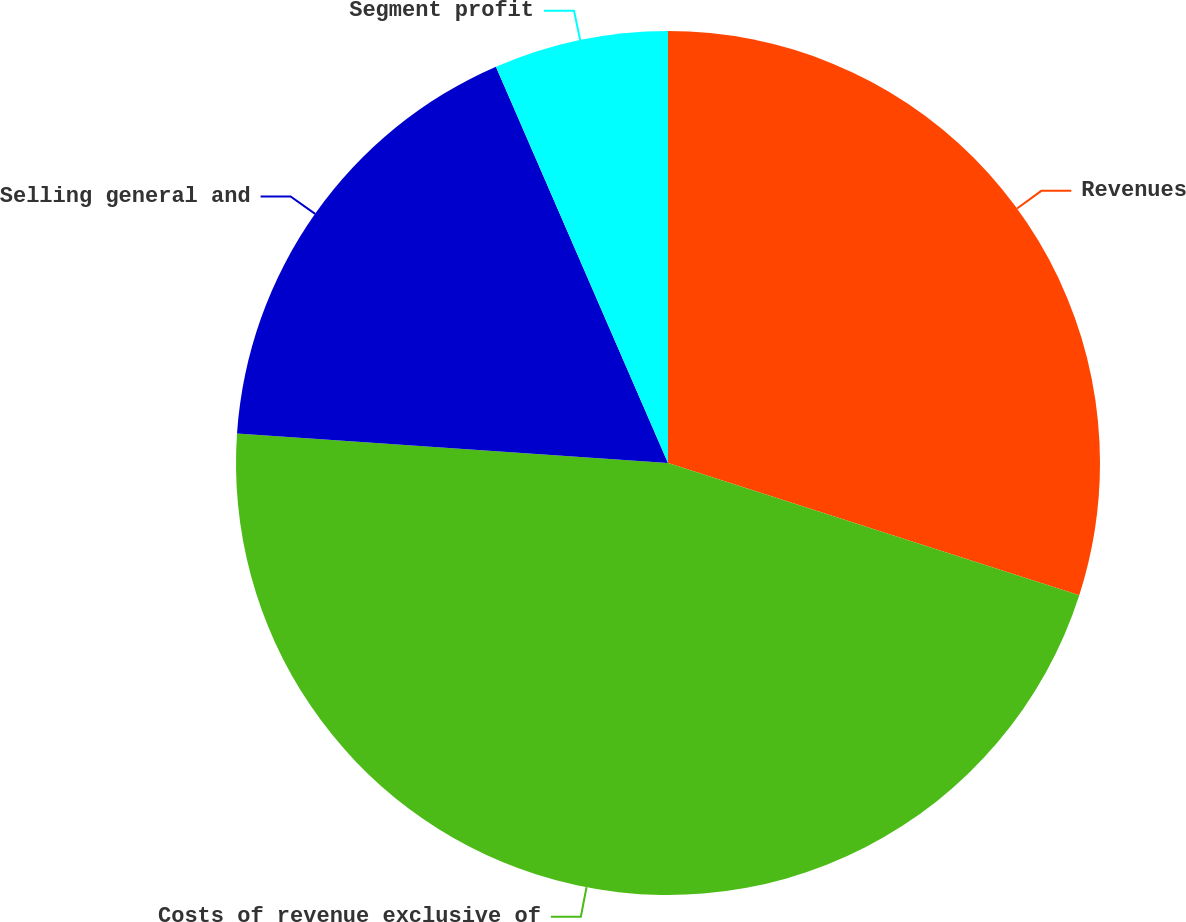Convert chart. <chart><loc_0><loc_0><loc_500><loc_500><pie_chart><fcel>Revenues<fcel>Costs of revenue exclusive of<fcel>Selling general and<fcel>Segment profit<nl><fcel>29.95%<fcel>46.14%<fcel>17.39%<fcel>6.52%<nl></chart> 